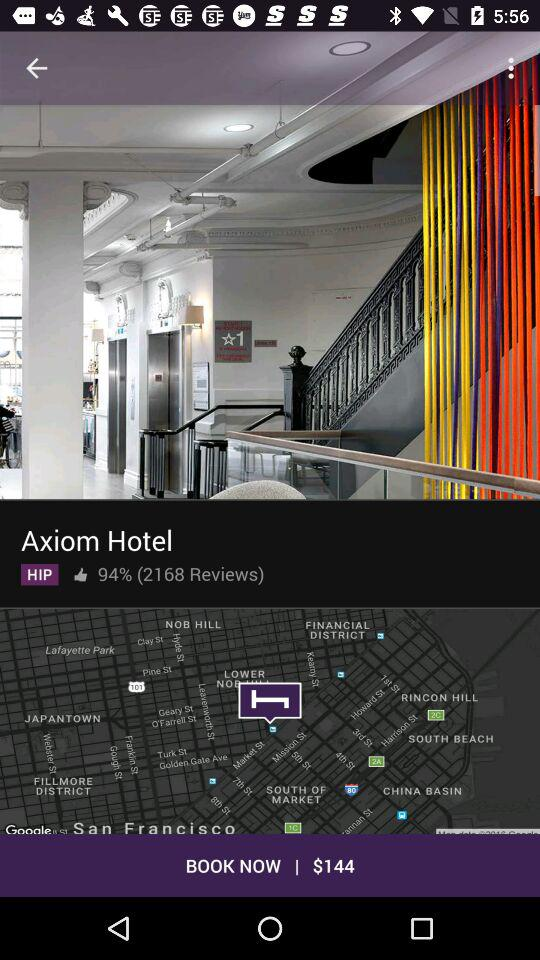What is the price of the Axiom Hotel? The price is $144. 